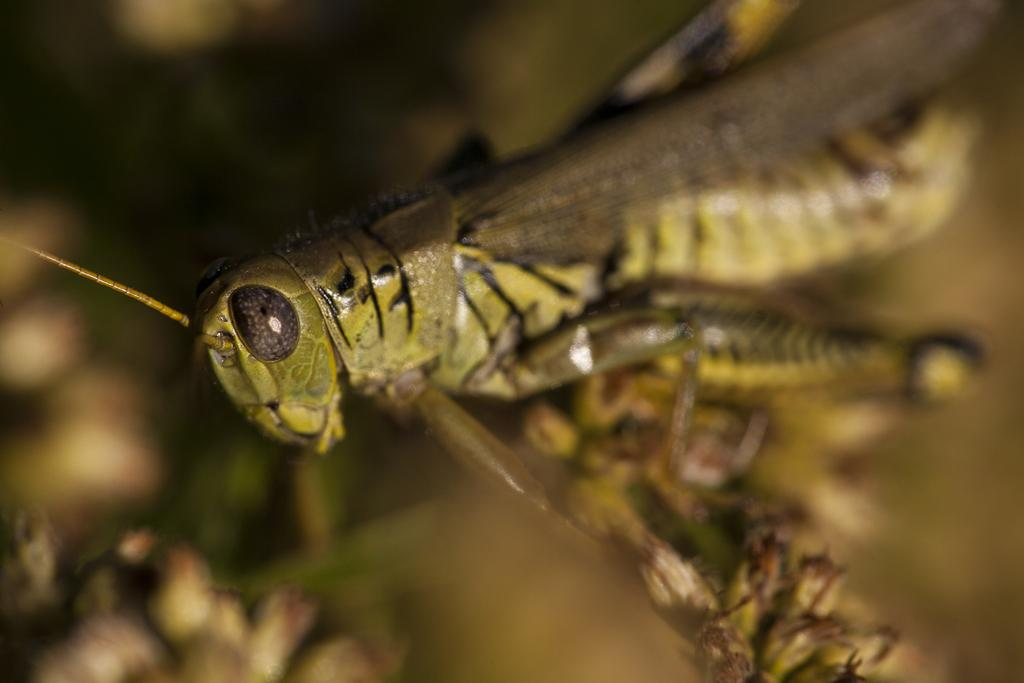What type of insect can be seen in the image? There is an insect in the image that resembles a grasshopper. What color is the background of the image? The background of the image is green. How is the image blurred? The image is blurred in the background. What theory is the insect trying to prove in the image? There is no indication in the image that the insect is trying to prove any theory. 